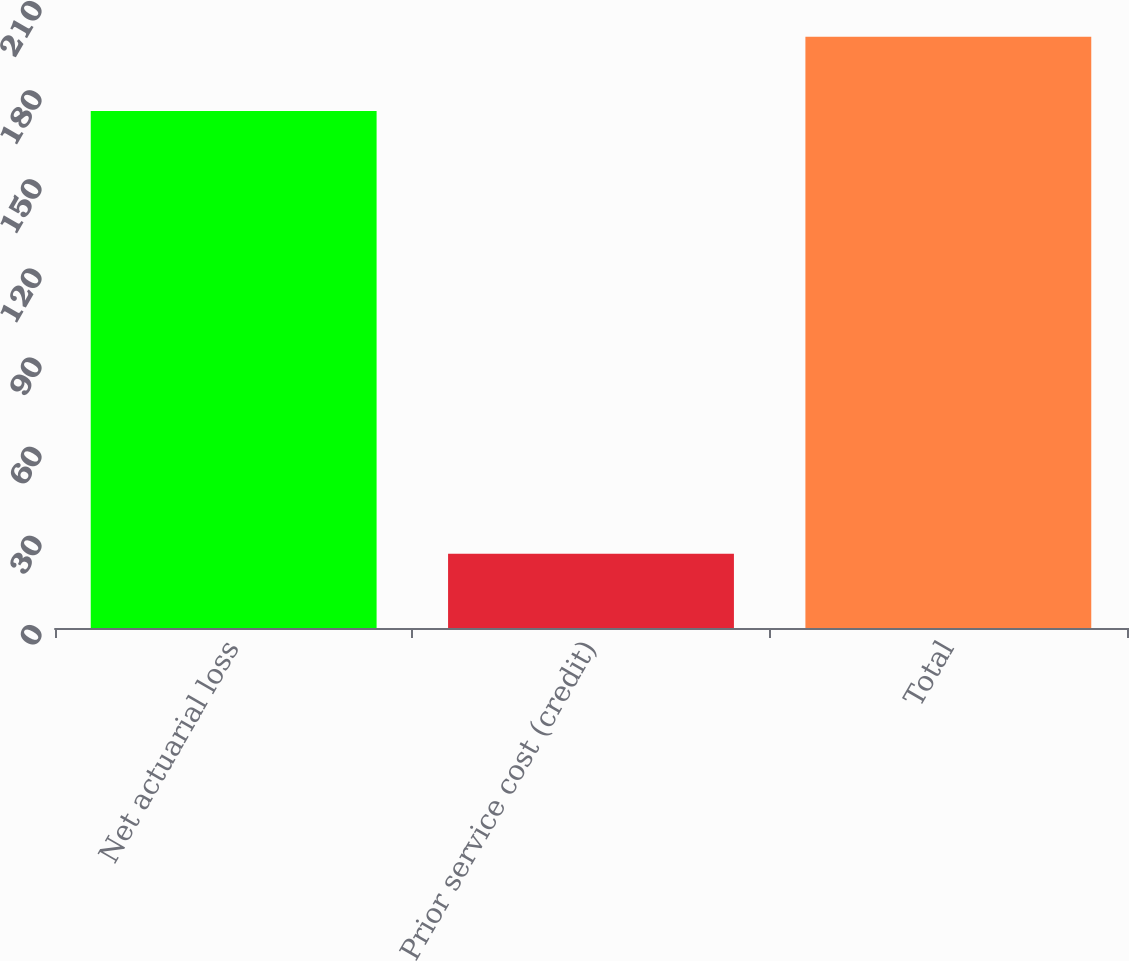Convert chart to OTSL. <chart><loc_0><loc_0><loc_500><loc_500><bar_chart><fcel>Net actuarial loss<fcel>Prior service cost (credit)<fcel>Total<nl><fcel>174<fcel>25<fcel>199<nl></chart> 